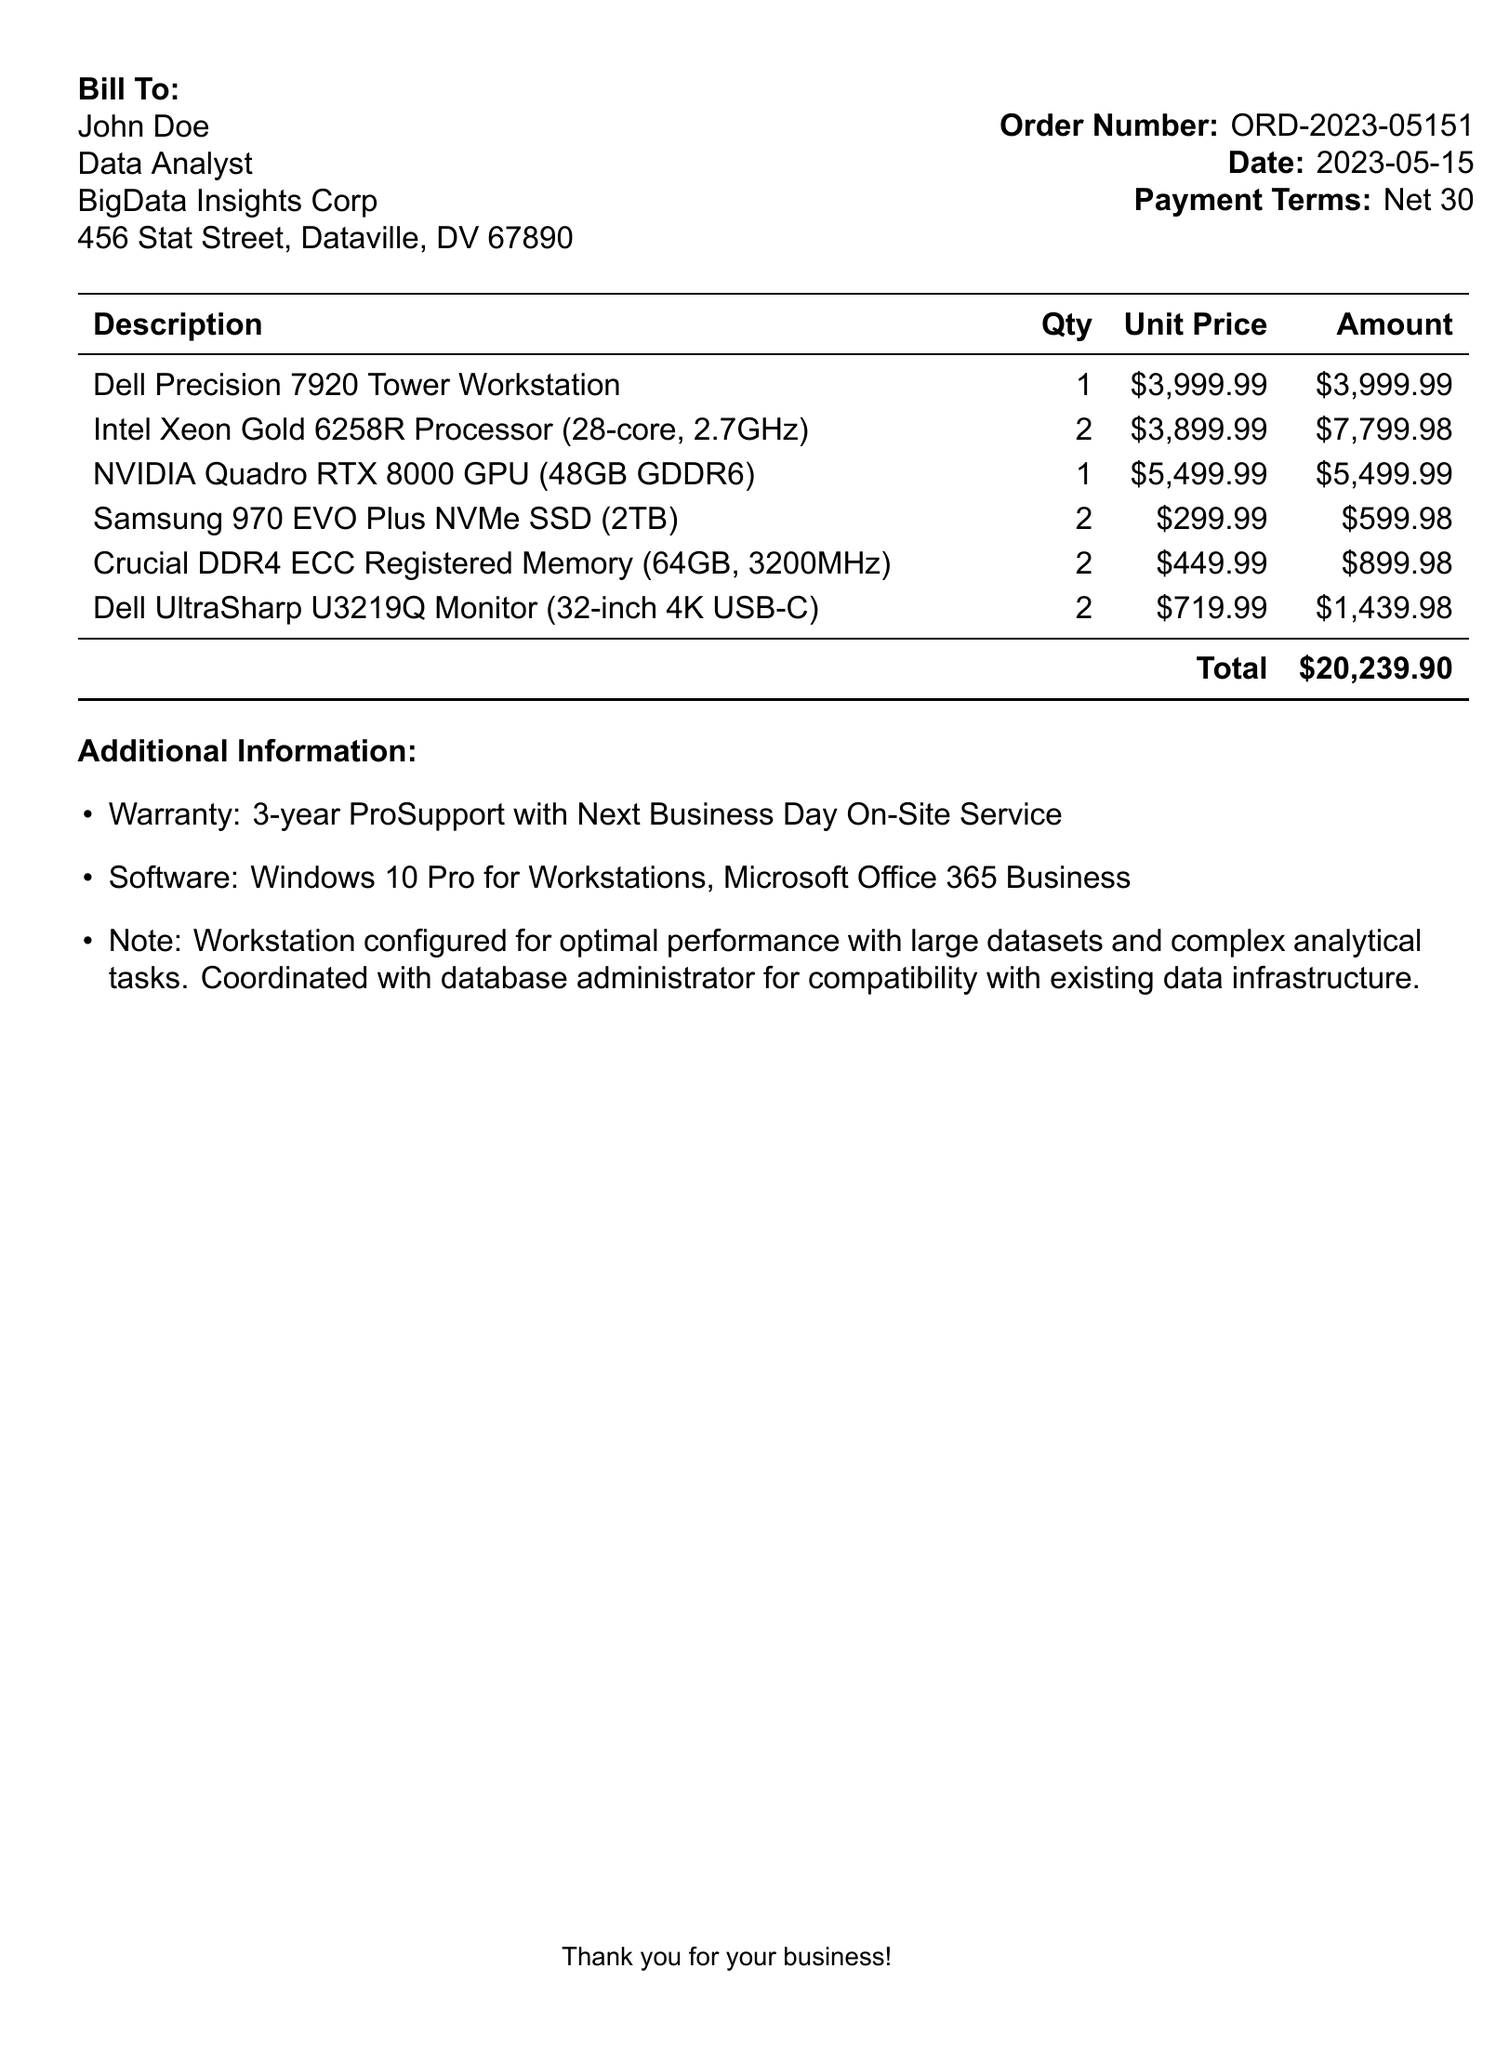What is the total amount for the workstation bill? The total amount is detailed in the summary section of the document, which is $20,239.90.
Answer: $20,239.90 Who is the bill addressed to? The document specifies the recipient, which is John Doe, noted in the billing section.
Answer: John Doe What is the order number? The order number is listed in the document, identifying this specific purchase transaction.
Answer: ORD-2023-05151 How many monitor units were purchased? The quantity of monitor units is provided in the itemized list, which indicates there were 2 units purchased.
Answer: 2 What warranty is offered with the equipment? The additional information section outlines the warranty terms, stating it is a 3-year ProSupport.
Answer: 3-year ProSupport with Next Business Day On-Site Service Which company sells the workstation? The header of the document contains the name of the selling company.
Answer: TechPro Solutions What type of software is included with the workstation? The document lists the included software under additional information, specifying Windows 10 Pro for Workstations and Microsoft Office 365 Business.
Answer: Windows 10 Pro for Workstations, Microsoft Office 365 Business How many Intel Xeon processors were ordered? The quantity of Intel Xeon processors can be found in the breakdown of hardware components in the invoice.
Answer: 2 What is the total cost of the NVIDIA Quadro RTX 8000 GPU? The price for the NVIDIA Quadro RTX 8000 GPU is in the itemized list, indicating one unit with its cost.
Answer: $5,499.99 